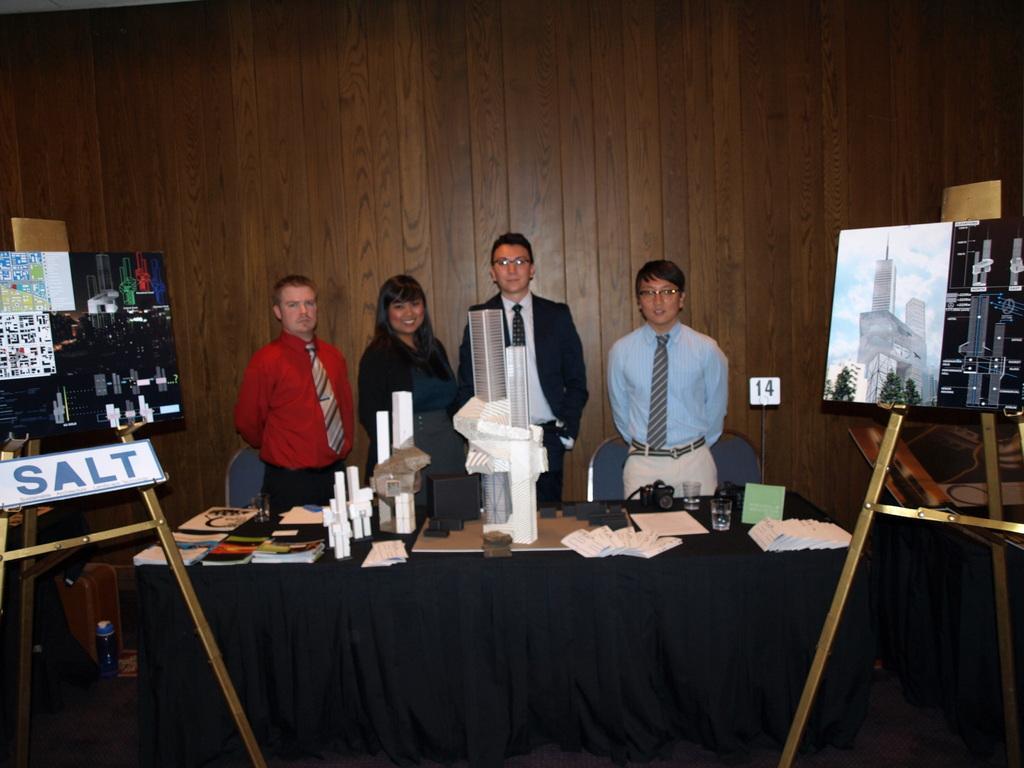Please provide a concise description of this image. In this image there are four person standing. On the table there is a book and some materials,camera and a glass. There is a board. 